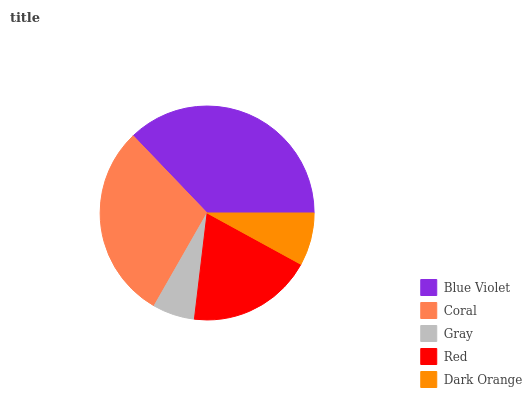Is Gray the minimum?
Answer yes or no. Yes. Is Blue Violet the maximum?
Answer yes or no. Yes. Is Coral the minimum?
Answer yes or no. No. Is Coral the maximum?
Answer yes or no. No. Is Blue Violet greater than Coral?
Answer yes or no. Yes. Is Coral less than Blue Violet?
Answer yes or no. Yes. Is Coral greater than Blue Violet?
Answer yes or no. No. Is Blue Violet less than Coral?
Answer yes or no. No. Is Red the high median?
Answer yes or no. Yes. Is Red the low median?
Answer yes or no. Yes. Is Gray the high median?
Answer yes or no. No. Is Blue Violet the low median?
Answer yes or no. No. 